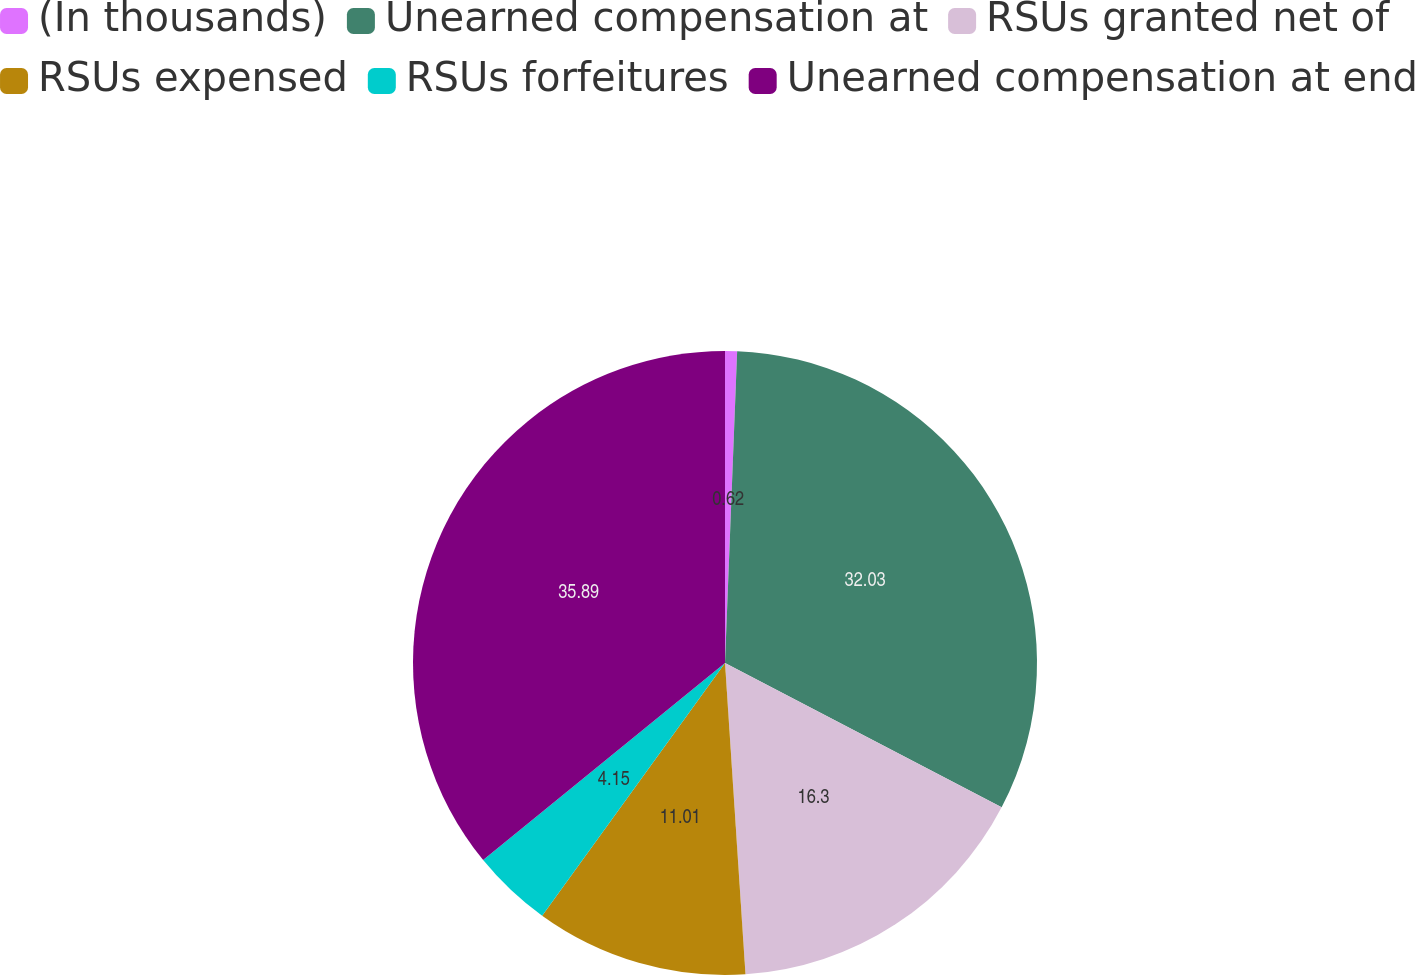Convert chart to OTSL. <chart><loc_0><loc_0><loc_500><loc_500><pie_chart><fcel>(In thousands)<fcel>Unearned compensation at<fcel>RSUs granted net of<fcel>RSUs expensed<fcel>RSUs forfeitures<fcel>Unearned compensation at end<nl><fcel>0.62%<fcel>32.03%<fcel>16.3%<fcel>11.01%<fcel>4.15%<fcel>35.88%<nl></chart> 